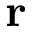<formula> <loc_0><loc_0><loc_500><loc_500>{ \delta r }</formula> 